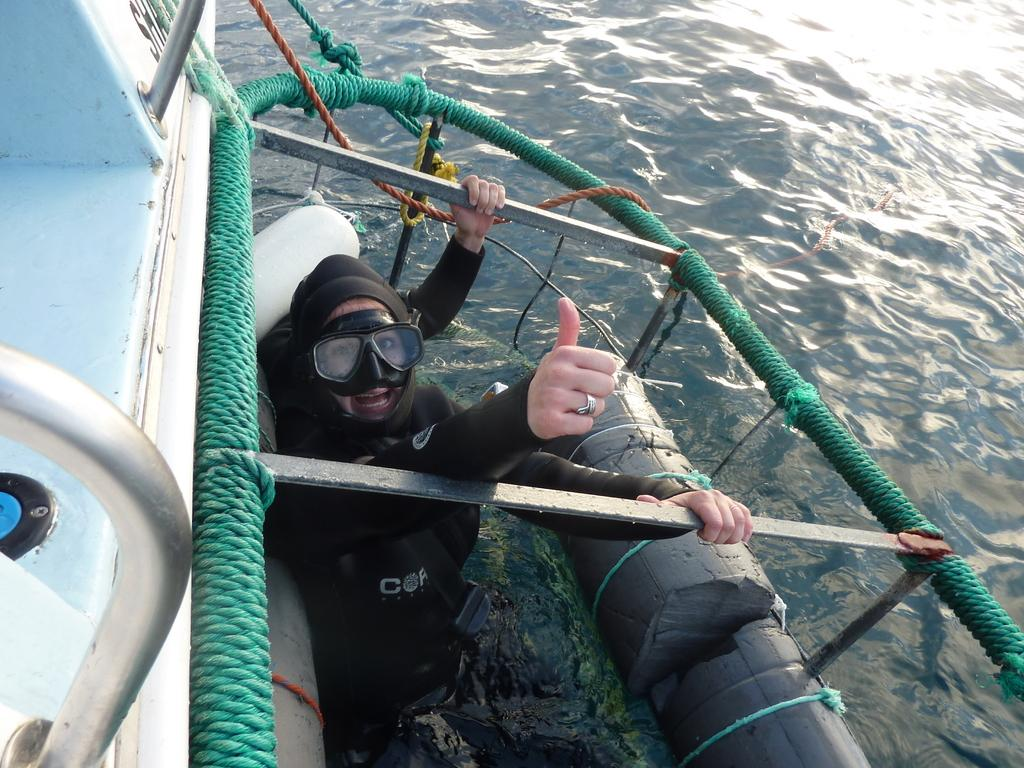What is the person in the image doing? There is a person in the water in the image. What can be seen on the left side of the image? There is a boat on the left side of the image. What is visible in the background of the image? There is water visible in the background of the image. What type of lizards can be seen driving a boat in the image? There are no lizards or boats being driven in the image. 